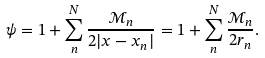<formula> <loc_0><loc_0><loc_500><loc_500>\psi = 1 + \sum _ { n } ^ { N } \frac { { \mathcal { M } } _ { n } } { 2 | { x } - { x } _ { n } | } = 1 + \sum _ { n } ^ { N } \frac { { \mathcal { M } } _ { n } } { 2 r _ { n } } .</formula> 